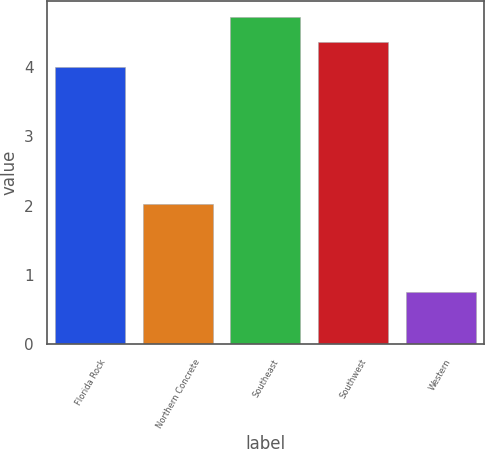Convert chart. <chart><loc_0><loc_0><loc_500><loc_500><bar_chart><fcel>Florida Rock<fcel>Northern Concrete<fcel>Southeast<fcel>Southwest<fcel>Western<nl><fcel>4<fcel>2.02<fcel>4.72<fcel>4.36<fcel>0.75<nl></chart> 